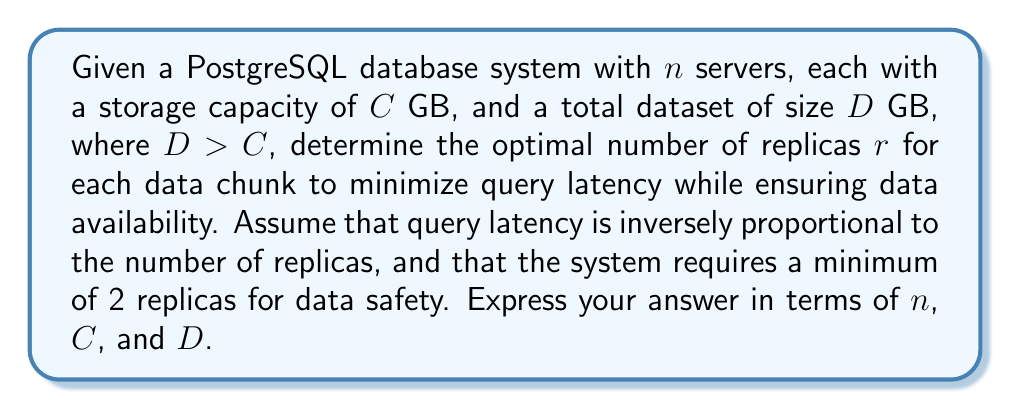Can you answer this question? To solve this problem, we need to consider the trade-off between data availability, storage capacity, and query latency. Let's approach this step-by-step:

1) First, we need to ensure that all data can be stored across the servers:
   $$n \cdot C \geq r \cdot D$$

2) We know that $r \geq 2$ for data safety.

3) The optimal number of replicas will be the maximum possible while still fitting within the storage constraints. This is because query latency is inversely proportional to the number of replicas.

4) We can express $r$ in terms of $n$, $C$, and $D$:
   $$r = \left\lfloor\frac{n \cdot C}{D}\right\rfloor$$

5) However, we need to ensure that $r \geq 2$. So our final expression for $r$ is:
   $$r = \max\left(2, \left\lfloor\frac{n \cdot C}{D}\right\rfloor\right)$$

This expression ensures that we have at least 2 replicas for data safety, but we use more if we have the storage capacity to do so, which will minimize query latency.
Answer: The optimal number of replicas $r$ is given by:

$$r = \max\left(2, \left\lfloor\frac{n \cdot C}{D}\right\rfloor\right)$$

where $n$ is the number of servers, $C$ is the storage capacity of each server in GB, and $D$ is the total dataset size in GB. 